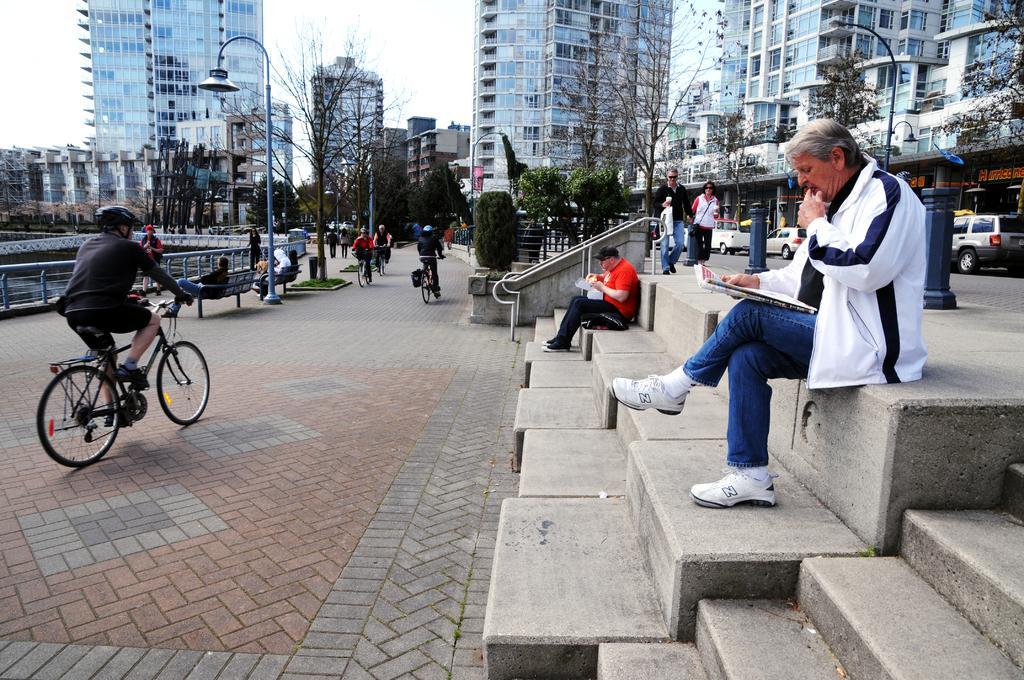In one or two sentences, can you explain what this image depicts? This picture describes about group of people, in the right side of the image a person is seated on the steps and reading news paper, in the left side of the given image a man is riding a bicycle, in the background we can see couple of poles, buildings and couple of trees. 